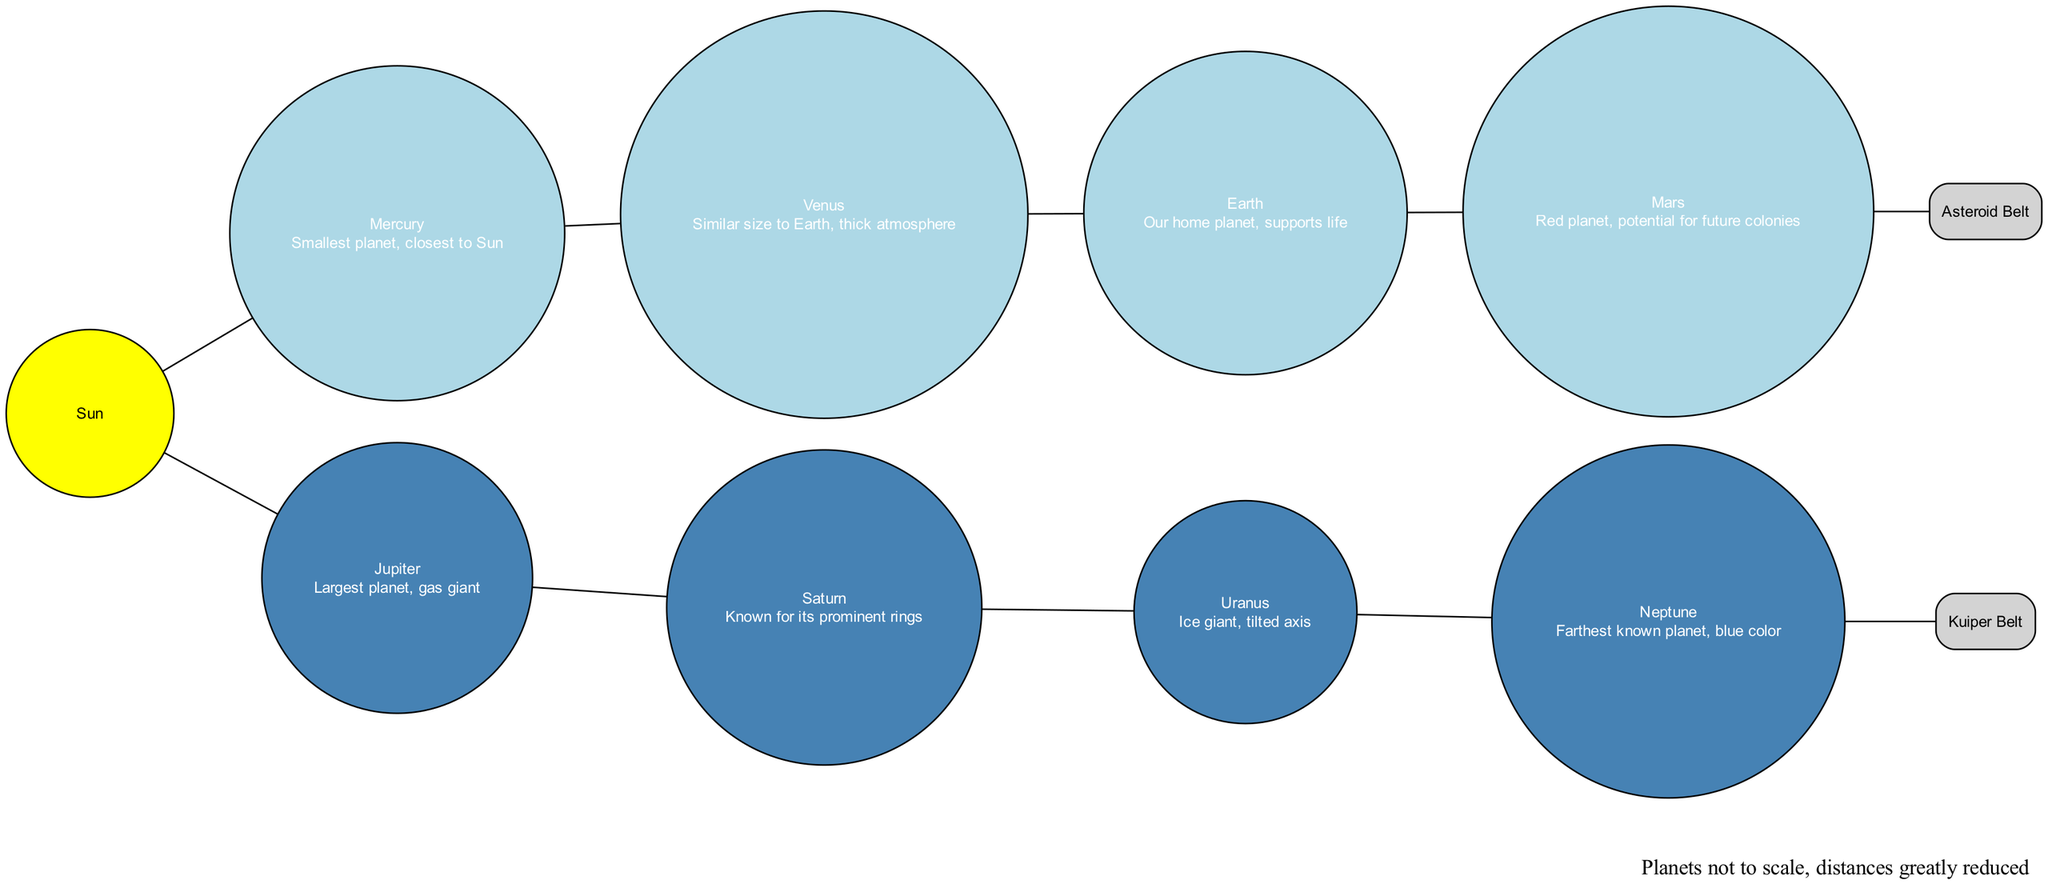What is the central object in this diagram? The diagram highlights the Sun as the central object in our solar system. It's placed at the center, clearly indicated with the label "Sun."
Answer: Sun How many inner planets are shown in the diagram? The diagram lists four inner planets: Mercury, Venus, Earth, and Mars, making the total count four.
Answer: 4 What planet is the largest in the solar system? Among all the planets presented in the diagram, Jupiter is labeled as the largest, confirming its status as the largest planet in the solar system.
Answer: Jupiter Which planet is closest to the Sun? Mercury is positioned closest to the Sun in the diagram, clearly indicated as the first of the inner planets, making it the nearest planet to the Sun.
Answer: Mercury What is the name of the region between Mars and Jupiter? The diagram identifies the Asteroid Belt as the region located between Mars and Jupiter, specifically labeled in a box to stand out.
Answer: Asteroid Belt Which planet is known for its prominent rings? Saturn is specified in the diagram as the planet known for its prominent rings, specifically mentioned in the description for Saturn.
Answer: Saturn What is the farthest known planet in this diagram? The last planet listed in the outer planets section is Neptune, which is described as the farthest known planet from the Sun in the solar system.
Answer: Neptune What does the Kuiper Belt contain? The diagram specifies that the Kuiper Belt is the region beyond Neptune and mentions that it contains Pluto, which is a significant detail about this region.
Answer: Pluto What color represents the outer planets in the diagram? The outer planets are represented in a steel blue color, as defined in the diagram’s code where this color is assigned to the outer planets.
Answer: Steel blue 